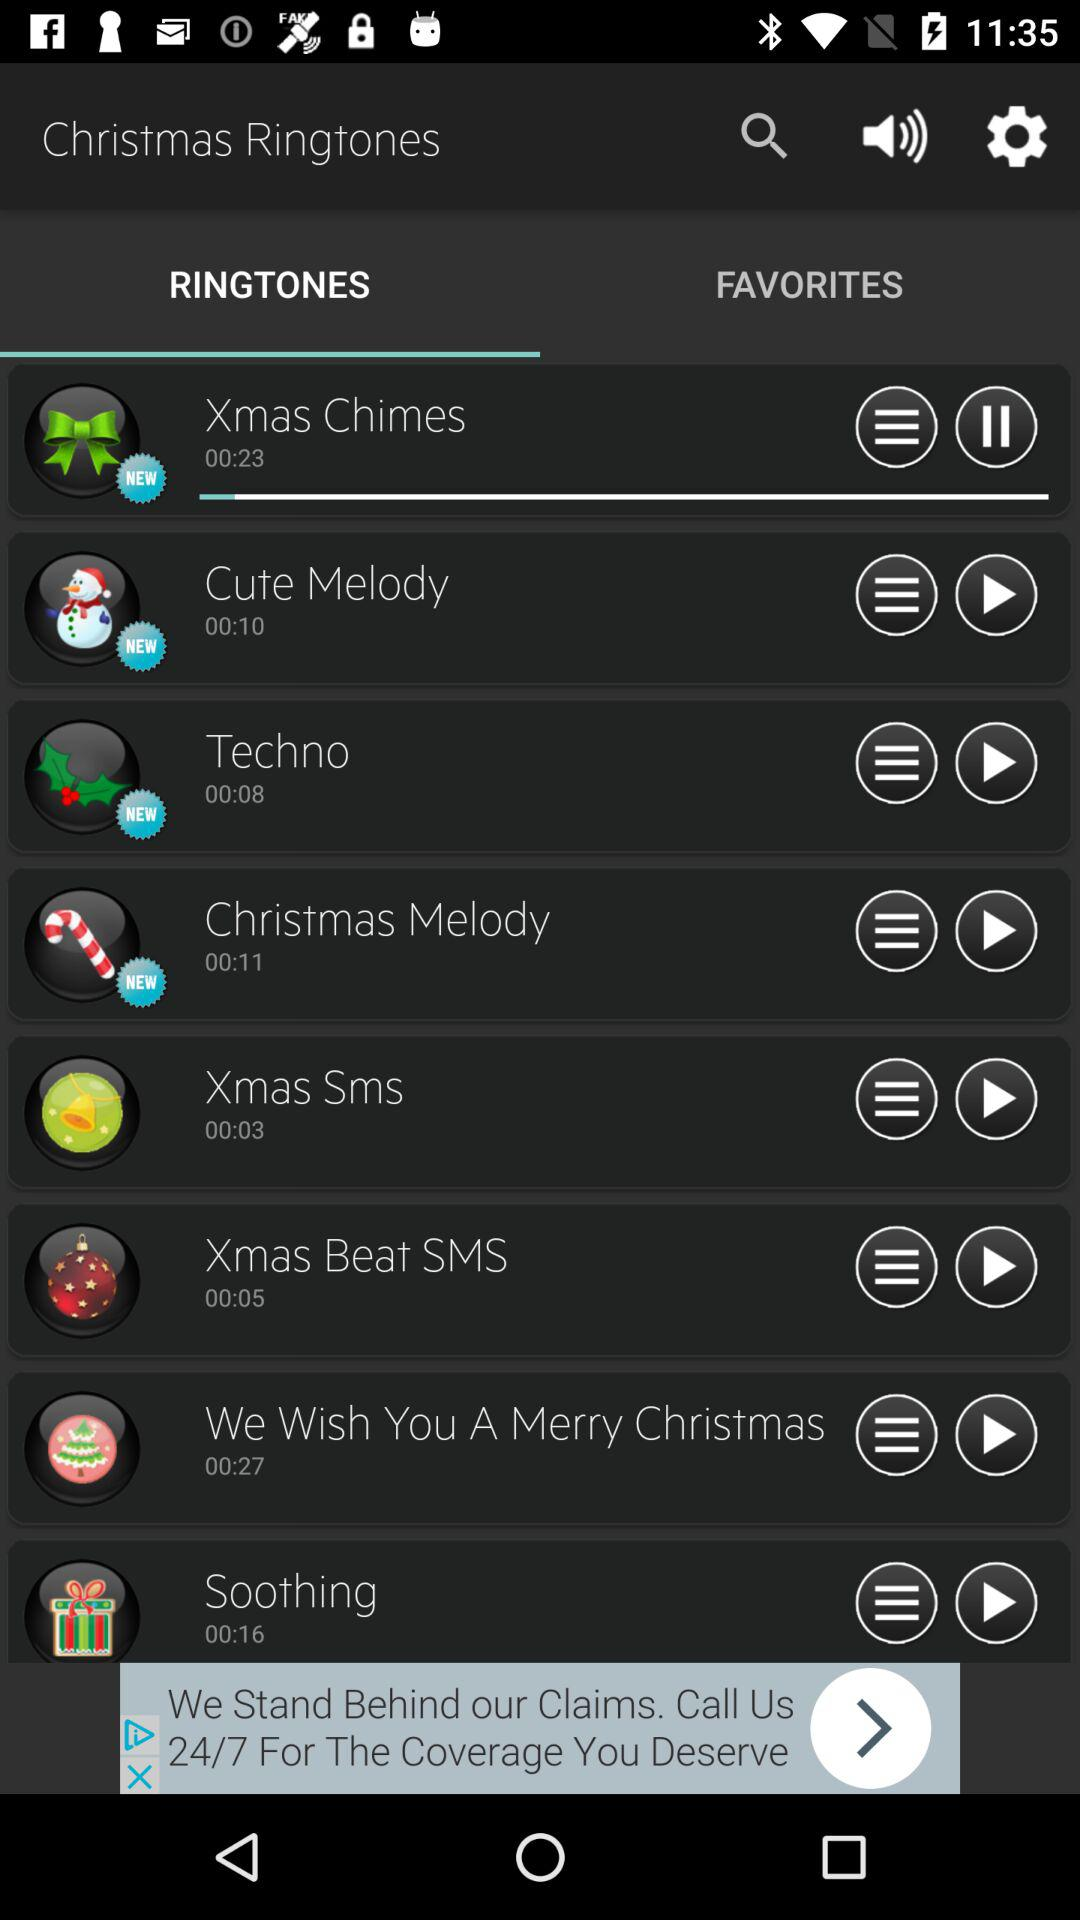What are the new ringtones? The new ringtones are "Xmas Chimes", "Cute Melody", "Techno" and "Christmas Melody". 